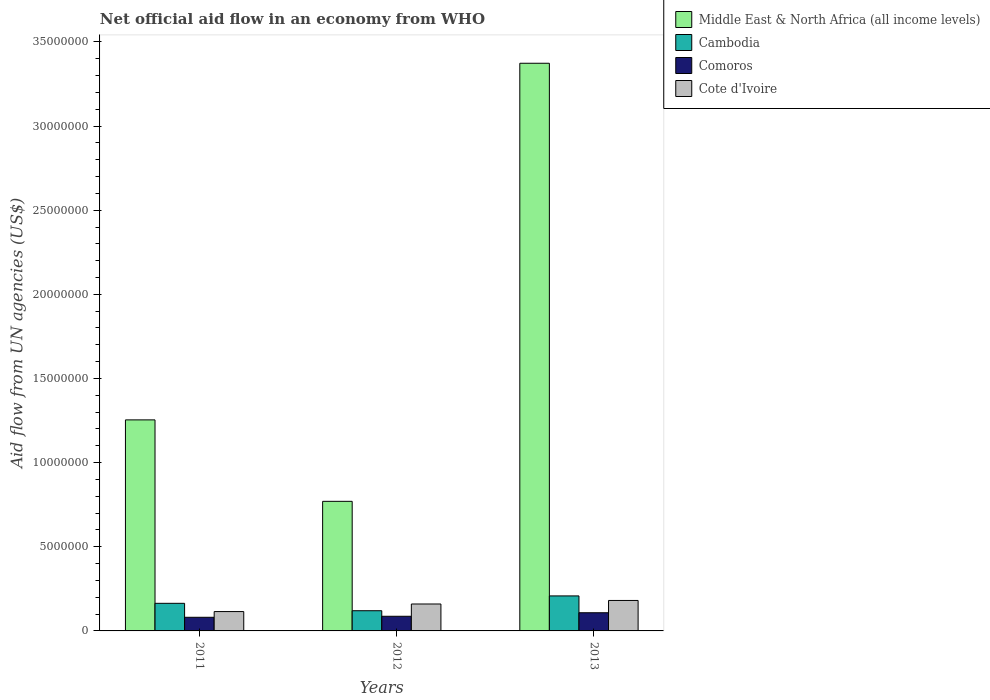Are the number of bars per tick equal to the number of legend labels?
Offer a terse response. Yes. Are the number of bars on each tick of the X-axis equal?
Your answer should be very brief. Yes. How many bars are there on the 3rd tick from the left?
Your answer should be compact. 4. What is the label of the 1st group of bars from the left?
Your answer should be compact. 2011. In how many cases, is the number of bars for a given year not equal to the number of legend labels?
Your answer should be very brief. 0. What is the net official aid flow in Cambodia in 2013?
Keep it short and to the point. 2.08e+06. Across all years, what is the maximum net official aid flow in Middle East & North Africa (all income levels)?
Offer a terse response. 3.37e+07. Across all years, what is the minimum net official aid flow in Comoros?
Your answer should be compact. 8.10e+05. In which year was the net official aid flow in Middle East & North Africa (all income levels) minimum?
Give a very brief answer. 2012. What is the total net official aid flow in Comoros in the graph?
Offer a terse response. 2.76e+06. What is the average net official aid flow in Comoros per year?
Ensure brevity in your answer.  9.20e+05. In the year 2013, what is the difference between the net official aid flow in Middle East & North Africa (all income levels) and net official aid flow in Cambodia?
Give a very brief answer. 3.16e+07. What is the ratio of the net official aid flow in Cambodia in 2011 to that in 2013?
Make the answer very short. 0.79. Is the net official aid flow in Comoros in 2011 less than that in 2012?
Keep it short and to the point. Yes. Is the difference between the net official aid flow in Middle East & North Africa (all income levels) in 2011 and 2013 greater than the difference between the net official aid flow in Cambodia in 2011 and 2013?
Ensure brevity in your answer.  No. What is the difference between the highest and the lowest net official aid flow in Middle East & North Africa (all income levels)?
Your response must be concise. 2.60e+07. In how many years, is the net official aid flow in Comoros greater than the average net official aid flow in Comoros taken over all years?
Your answer should be very brief. 1. What does the 4th bar from the left in 2012 represents?
Give a very brief answer. Cote d'Ivoire. What does the 3rd bar from the right in 2011 represents?
Ensure brevity in your answer.  Cambodia. How many bars are there?
Ensure brevity in your answer.  12. What is the difference between two consecutive major ticks on the Y-axis?
Make the answer very short. 5.00e+06. Are the values on the major ticks of Y-axis written in scientific E-notation?
Offer a very short reply. No. Does the graph contain any zero values?
Offer a terse response. No. How are the legend labels stacked?
Your answer should be very brief. Vertical. What is the title of the graph?
Offer a very short reply. Net official aid flow in an economy from WHO. Does "Gabon" appear as one of the legend labels in the graph?
Your answer should be very brief. No. What is the label or title of the Y-axis?
Provide a short and direct response. Aid flow from UN agencies (US$). What is the Aid flow from UN agencies (US$) of Middle East & North Africa (all income levels) in 2011?
Offer a very short reply. 1.25e+07. What is the Aid flow from UN agencies (US$) of Cambodia in 2011?
Give a very brief answer. 1.64e+06. What is the Aid flow from UN agencies (US$) of Comoros in 2011?
Offer a very short reply. 8.10e+05. What is the Aid flow from UN agencies (US$) of Cote d'Ivoire in 2011?
Offer a very short reply. 1.15e+06. What is the Aid flow from UN agencies (US$) in Middle East & North Africa (all income levels) in 2012?
Ensure brevity in your answer.  7.70e+06. What is the Aid flow from UN agencies (US$) in Cambodia in 2012?
Provide a succinct answer. 1.20e+06. What is the Aid flow from UN agencies (US$) of Comoros in 2012?
Offer a terse response. 8.70e+05. What is the Aid flow from UN agencies (US$) of Cote d'Ivoire in 2012?
Offer a very short reply. 1.60e+06. What is the Aid flow from UN agencies (US$) of Middle East & North Africa (all income levels) in 2013?
Give a very brief answer. 3.37e+07. What is the Aid flow from UN agencies (US$) in Cambodia in 2013?
Make the answer very short. 2.08e+06. What is the Aid flow from UN agencies (US$) of Comoros in 2013?
Provide a succinct answer. 1.08e+06. What is the Aid flow from UN agencies (US$) of Cote d'Ivoire in 2013?
Offer a very short reply. 1.81e+06. Across all years, what is the maximum Aid flow from UN agencies (US$) in Middle East & North Africa (all income levels)?
Provide a short and direct response. 3.37e+07. Across all years, what is the maximum Aid flow from UN agencies (US$) of Cambodia?
Ensure brevity in your answer.  2.08e+06. Across all years, what is the maximum Aid flow from UN agencies (US$) in Comoros?
Ensure brevity in your answer.  1.08e+06. Across all years, what is the maximum Aid flow from UN agencies (US$) in Cote d'Ivoire?
Your response must be concise. 1.81e+06. Across all years, what is the minimum Aid flow from UN agencies (US$) of Middle East & North Africa (all income levels)?
Provide a short and direct response. 7.70e+06. Across all years, what is the minimum Aid flow from UN agencies (US$) of Cambodia?
Provide a succinct answer. 1.20e+06. Across all years, what is the minimum Aid flow from UN agencies (US$) in Comoros?
Keep it short and to the point. 8.10e+05. Across all years, what is the minimum Aid flow from UN agencies (US$) of Cote d'Ivoire?
Offer a terse response. 1.15e+06. What is the total Aid flow from UN agencies (US$) in Middle East & North Africa (all income levels) in the graph?
Make the answer very short. 5.40e+07. What is the total Aid flow from UN agencies (US$) of Cambodia in the graph?
Keep it short and to the point. 4.92e+06. What is the total Aid flow from UN agencies (US$) of Comoros in the graph?
Provide a short and direct response. 2.76e+06. What is the total Aid flow from UN agencies (US$) of Cote d'Ivoire in the graph?
Your answer should be compact. 4.56e+06. What is the difference between the Aid flow from UN agencies (US$) in Middle East & North Africa (all income levels) in 2011 and that in 2012?
Keep it short and to the point. 4.84e+06. What is the difference between the Aid flow from UN agencies (US$) of Cambodia in 2011 and that in 2012?
Give a very brief answer. 4.40e+05. What is the difference between the Aid flow from UN agencies (US$) in Cote d'Ivoire in 2011 and that in 2012?
Make the answer very short. -4.50e+05. What is the difference between the Aid flow from UN agencies (US$) of Middle East & North Africa (all income levels) in 2011 and that in 2013?
Ensure brevity in your answer.  -2.12e+07. What is the difference between the Aid flow from UN agencies (US$) of Cambodia in 2011 and that in 2013?
Your answer should be compact. -4.40e+05. What is the difference between the Aid flow from UN agencies (US$) in Cote d'Ivoire in 2011 and that in 2013?
Your answer should be very brief. -6.60e+05. What is the difference between the Aid flow from UN agencies (US$) of Middle East & North Africa (all income levels) in 2012 and that in 2013?
Provide a short and direct response. -2.60e+07. What is the difference between the Aid flow from UN agencies (US$) of Cambodia in 2012 and that in 2013?
Keep it short and to the point. -8.80e+05. What is the difference between the Aid flow from UN agencies (US$) in Cote d'Ivoire in 2012 and that in 2013?
Your answer should be compact. -2.10e+05. What is the difference between the Aid flow from UN agencies (US$) of Middle East & North Africa (all income levels) in 2011 and the Aid flow from UN agencies (US$) of Cambodia in 2012?
Offer a terse response. 1.13e+07. What is the difference between the Aid flow from UN agencies (US$) of Middle East & North Africa (all income levels) in 2011 and the Aid flow from UN agencies (US$) of Comoros in 2012?
Offer a terse response. 1.17e+07. What is the difference between the Aid flow from UN agencies (US$) of Middle East & North Africa (all income levels) in 2011 and the Aid flow from UN agencies (US$) of Cote d'Ivoire in 2012?
Offer a very short reply. 1.09e+07. What is the difference between the Aid flow from UN agencies (US$) in Cambodia in 2011 and the Aid flow from UN agencies (US$) in Comoros in 2012?
Your answer should be very brief. 7.70e+05. What is the difference between the Aid flow from UN agencies (US$) in Comoros in 2011 and the Aid flow from UN agencies (US$) in Cote d'Ivoire in 2012?
Ensure brevity in your answer.  -7.90e+05. What is the difference between the Aid flow from UN agencies (US$) in Middle East & North Africa (all income levels) in 2011 and the Aid flow from UN agencies (US$) in Cambodia in 2013?
Provide a short and direct response. 1.05e+07. What is the difference between the Aid flow from UN agencies (US$) in Middle East & North Africa (all income levels) in 2011 and the Aid flow from UN agencies (US$) in Comoros in 2013?
Ensure brevity in your answer.  1.15e+07. What is the difference between the Aid flow from UN agencies (US$) in Middle East & North Africa (all income levels) in 2011 and the Aid flow from UN agencies (US$) in Cote d'Ivoire in 2013?
Keep it short and to the point. 1.07e+07. What is the difference between the Aid flow from UN agencies (US$) in Cambodia in 2011 and the Aid flow from UN agencies (US$) in Comoros in 2013?
Provide a short and direct response. 5.60e+05. What is the difference between the Aid flow from UN agencies (US$) in Cambodia in 2011 and the Aid flow from UN agencies (US$) in Cote d'Ivoire in 2013?
Keep it short and to the point. -1.70e+05. What is the difference between the Aid flow from UN agencies (US$) in Middle East & North Africa (all income levels) in 2012 and the Aid flow from UN agencies (US$) in Cambodia in 2013?
Offer a terse response. 5.62e+06. What is the difference between the Aid flow from UN agencies (US$) in Middle East & North Africa (all income levels) in 2012 and the Aid flow from UN agencies (US$) in Comoros in 2013?
Your answer should be very brief. 6.62e+06. What is the difference between the Aid flow from UN agencies (US$) of Middle East & North Africa (all income levels) in 2012 and the Aid flow from UN agencies (US$) of Cote d'Ivoire in 2013?
Provide a succinct answer. 5.89e+06. What is the difference between the Aid flow from UN agencies (US$) of Cambodia in 2012 and the Aid flow from UN agencies (US$) of Cote d'Ivoire in 2013?
Make the answer very short. -6.10e+05. What is the difference between the Aid flow from UN agencies (US$) in Comoros in 2012 and the Aid flow from UN agencies (US$) in Cote d'Ivoire in 2013?
Your response must be concise. -9.40e+05. What is the average Aid flow from UN agencies (US$) in Middle East & North Africa (all income levels) per year?
Provide a succinct answer. 1.80e+07. What is the average Aid flow from UN agencies (US$) of Cambodia per year?
Your response must be concise. 1.64e+06. What is the average Aid flow from UN agencies (US$) of Comoros per year?
Provide a succinct answer. 9.20e+05. What is the average Aid flow from UN agencies (US$) of Cote d'Ivoire per year?
Ensure brevity in your answer.  1.52e+06. In the year 2011, what is the difference between the Aid flow from UN agencies (US$) in Middle East & North Africa (all income levels) and Aid flow from UN agencies (US$) in Cambodia?
Keep it short and to the point. 1.09e+07. In the year 2011, what is the difference between the Aid flow from UN agencies (US$) of Middle East & North Africa (all income levels) and Aid flow from UN agencies (US$) of Comoros?
Your answer should be very brief. 1.17e+07. In the year 2011, what is the difference between the Aid flow from UN agencies (US$) of Middle East & North Africa (all income levels) and Aid flow from UN agencies (US$) of Cote d'Ivoire?
Keep it short and to the point. 1.14e+07. In the year 2011, what is the difference between the Aid flow from UN agencies (US$) in Cambodia and Aid flow from UN agencies (US$) in Comoros?
Provide a short and direct response. 8.30e+05. In the year 2012, what is the difference between the Aid flow from UN agencies (US$) in Middle East & North Africa (all income levels) and Aid flow from UN agencies (US$) in Cambodia?
Give a very brief answer. 6.50e+06. In the year 2012, what is the difference between the Aid flow from UN agencies (US$) in Middle East & North Africa (all income levels) and Aid flow from UN agencies (US$) in Comoros?
Ensure brevity in your answer.  6.83e+06. In the year 2012, what is the difference between the Aid flow from UN agencies (US$) of Middle East & North Africa (all income levels) and Aid flow from UN agencies (US$) of Cote d'Ivoire?
Offer a very short reply. 6.10e+06. In the year 2012, what is the difference between the Aid flow from UN agencies (US$) of Cambodia and Aid flow from UN agencies (US$) of Cote d'Ivoire?
Your answer should be compact. -4.00e+05. In the year 2012, what is the difference between the Aid flow from UN agencies (US$) in Comoros and Aid flow from UN agencies (US$) in Cote d'Ivoire?
Make the answer very short. -7.30e+05. In the year 2013, what is the difference between the Aid flow from UN agencies (US$) in Middle East & North Africa (all income levels) and Aid flow from UN agencies (US$) in Cambodia?
Your answer should be compact. 3.16e+07. In the year 2013, what is the difference between the Aid flow from UN agencies (US$) of Middle East & North Africa (all income levels) and Aid flow from UN agencies (US$) of Comoros?
Provide a short and direct response. 3.26e+07. In the year 2013, what is the difference between the Aid flow from UN agencies (US$) of Middle East & North Africa (all income levels) and Aid flow from UN agencies (US$) of Cote d'Ivoire?
Give a very brief answer. 3.19e+07. In the year 2013, what is the difference between the Aid flow from UN agencies (US$) in Cambodia and Aid flow from UN agencies (US$) in Cote d'Ivoire?
Make the answer very short. 2.70e+05. In the year 2013, what is the difference between the Aid flow from UN agencies (US$) of Comoros and Aid flow from UN agencies (US$) of Cote d'Ivoire?
Provide a succinct answer. -7.30e+05. What is the ratio of the Aid flow from UN agencies (US$) of Middle East & North Africa (all income levels) in 2011 to that in 2012?
Your answer should be compact. 1.63. What is the ratio of the Aid flow from UN agencies (US$) of Cambodia in 2011 to that in 2012?
Keep it short and to the point. 1.37. What is the ratio of the Aid flow from UN agencies (US$) of Cote d'Ivoire in 2011 to that in 2012?
Keep it short and to the point. 0.72. What is the ratio of the Aid flow from UN agencies (US$) in Middle East & North Africa (all income levels) in 2011 to that in 2013?
Make the answer very short. 0.37. What is the ratio of the Aid flow from UN agencies (US$) in Cambodia in 2011 to that in 2013?
Keep it short and to the point. 0.79. What is the ratio of the Aid flow from UN agencies (US$) in Comoros in 2011 to that in 2013?
Provide a succinct answer. 0.75. What is the ratio of the Aid flow from UN agencies (US$) of Cote d'Ivoire in 2011 to that in 2013?
Your response must be concise. 0.64. What is the ratio of the Aid flow from UN agencies (US$) in Middle East & North Africa (all income levels) in 2012 to that in 2013?
Provide a short and direct response. 0.23. What is the ratio of the Aid flow from UN agencies (US$) in Cambodia in 2012 to that in 2013?
Give a very brief answer. 0.58. What is the ratio of the Aid flow from UN agencies (US$) of Comoros in 2012 to that in 2013?
Ensure brevity in your answer.  0.81. What is the ratio of the Aid flow from UN agencies (US$) of Cote d'Ivoire in 2012 to that in 2013?
Offer a terse response. 0.88. What is the difference between the highest and the second highest Aid flow from UN agencies (US$) in Middle East & North Africa (all income levels)?
Give a very brief answer. 2.12e+07. What is the difference between the highest and the second highest Aid flow from UN agencies (US$) of Cote d'Ivoire?
Your answer should be very brief. 2.10e+05. What is the difference between the highest and the lowest Aid flow from UN agencies (US$) in Middle East & North Africa (all income levels)?
Your answer should be very brief. 2.60e+07. What is the difference between the highest and the lowest Aid flow from UN agencies (US$) of Cambodia?
Your answer should be compact. 8.80e+05. What is the difference between the highest and the lowest Aid flow from UN agencies (US$) in Comoros?
Make the answer very short. 2.70e+05. What is the difference between the highest and the lowest Aid flow from UN agencies (US$) of Cote d'Ivoire?
Offer a terse response. 6.60e+05. 